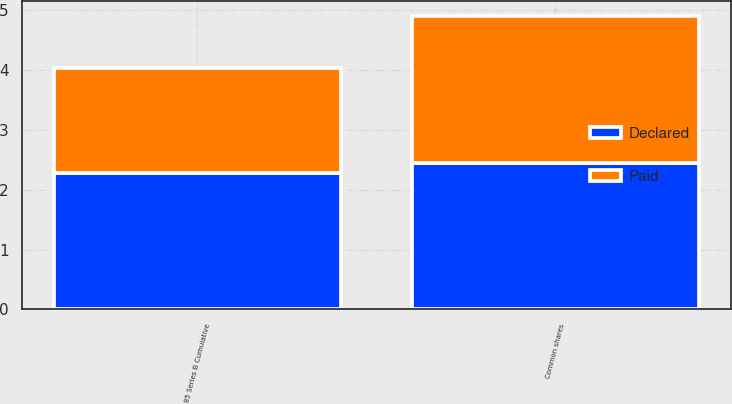<chart> <loc_0><loc_0><loc_500><loc_500><stacked_bar_chart><ecel><fcel>Common shares<fcel>85 Series B Cumulative<nl><fcel>Paid<fcel>2.46<fcel>1.75<nl><fcel>Declared<fcel>2.44<fcel>2.28<nl></chart> 